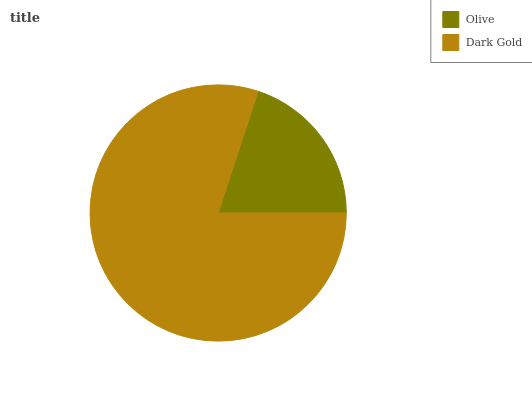Is Olive the minimum?
Answer yes or no. Yes. Is Dark Gold the maximum?
Answer yes or no. Yes. Is Dark Gold the minimum?
Answer yes or no. No. Is Dark Gold greater than Olive?
Answer yes or no. Yes. Is Olive less than Dark Gold?
Answer yes or no. Yes. Is Olive greater than Dark Gold?
Answer yes or no. No. Is Dark Gold less than Olive?
Answer yes or no. No. Is Dark Gold the high median?
Answer yes or no. Yes. Is Olive the low median?
Answer yes or no. Yes. Is Olive the high median?
Answer yes or no. No. Is Dark Gold the low median?
Answer yes or no. No. 